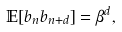<formula> <loc_0><loc_0><loc_500><loc_500>\mathbb { E } [ b _ { n } b _ { n + d } ] = \beta ^ { d } ,</formula> 